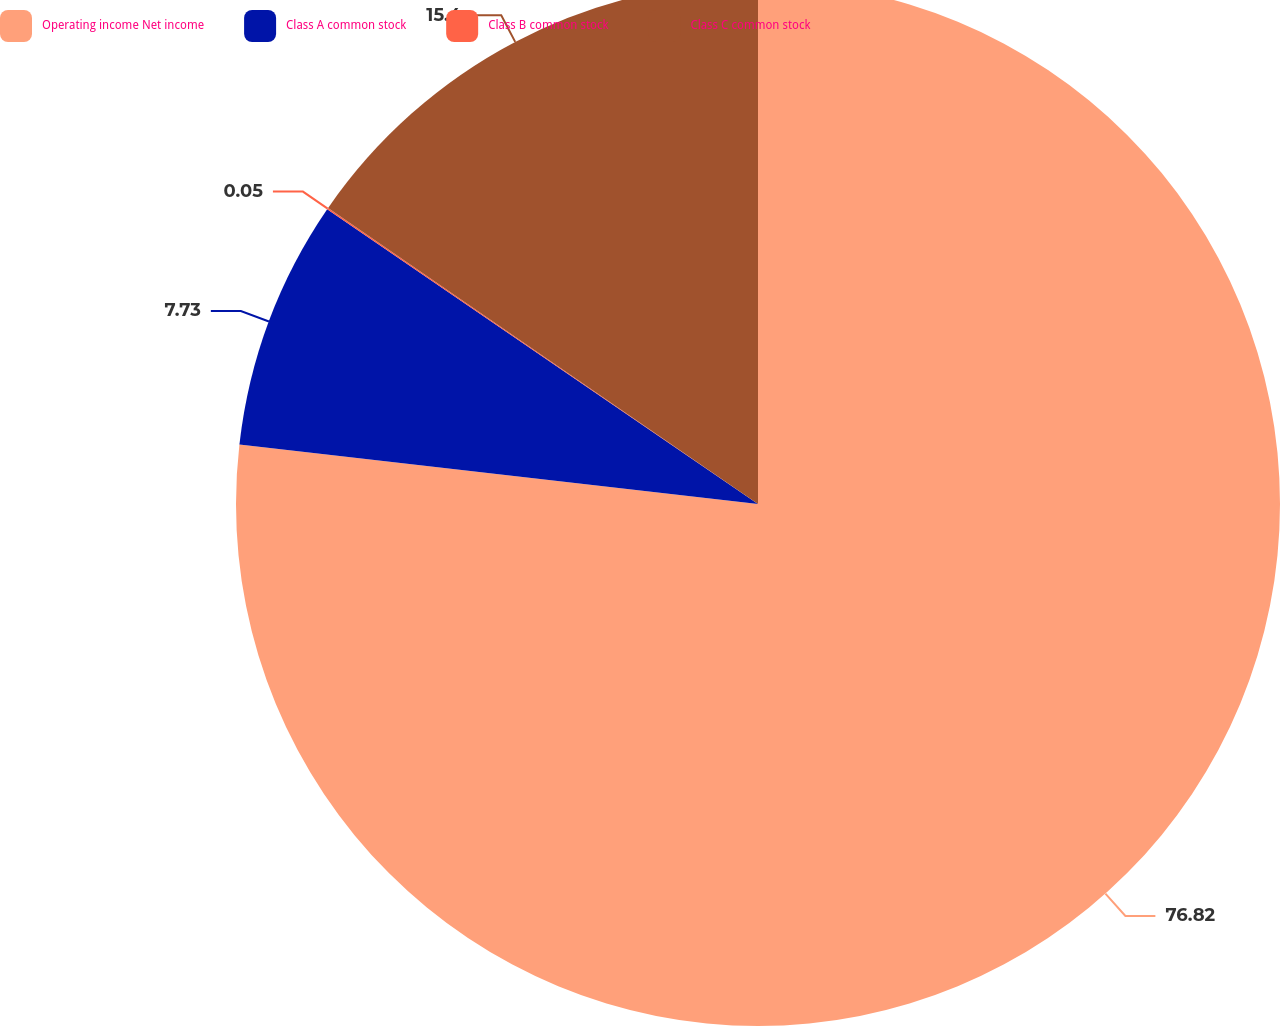Convert chart to OTSL. <chart><loc_0><loc_0><loc_500><loc_500><pie_chart><fcel>Operating income Net income<fcel>Class A common stock<fcel>Class B common stock<fcel>Class C common stock<nl><fcel>76.82%<fcel>7.73%<fcel>0.05%<fcel>15.4%<nl></chart> 